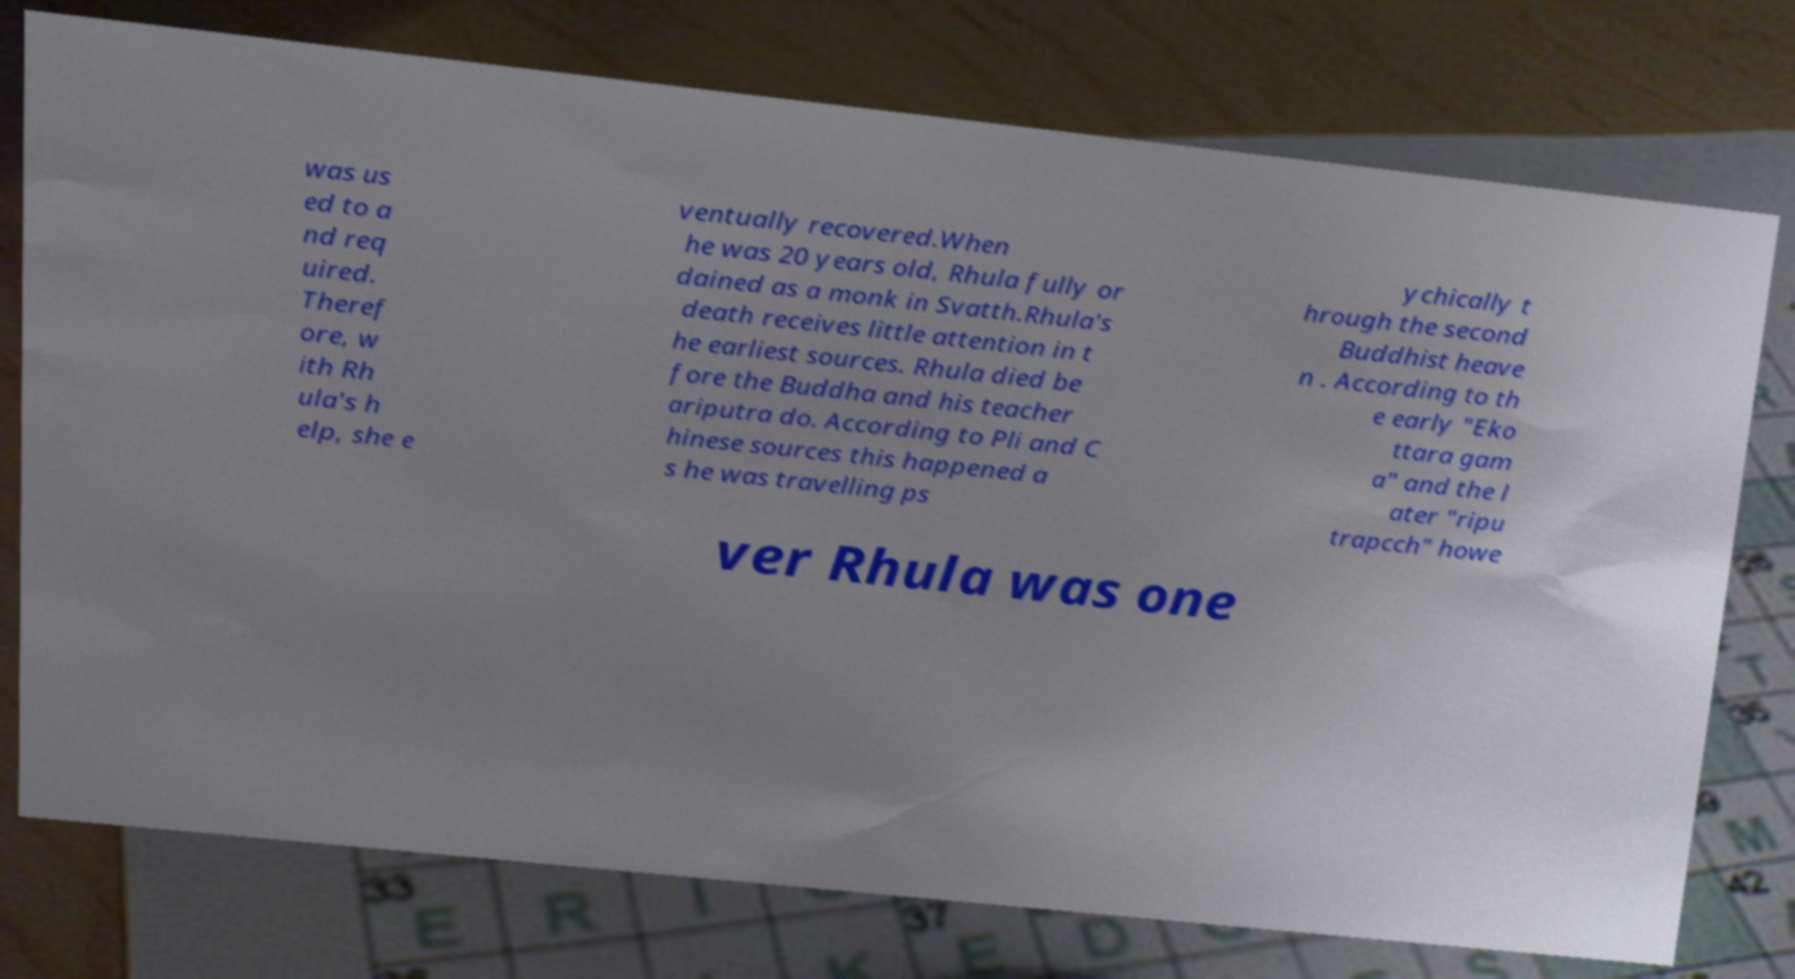For documentation purposes, I need the text within this image transcribed. Could you provide that? was us ed to a nd req uired. Theref ore, w ith Rh ula's h elp, she e ventually recovered.When he was 20 years old, Rhula fully or dained as a monk in Svatth.Rhula's death receives little attention in t he earliest sources. Rhula died be fore the Buddha and his teacher ariputra do. According to Pli and C hinese sources this happened a s he was travelling ps ychically t hrough the second Buddhist heave n . According to th e early "Eko ttara gam a" and the l ater "ripu trapcch" howe ver Rhula was one 